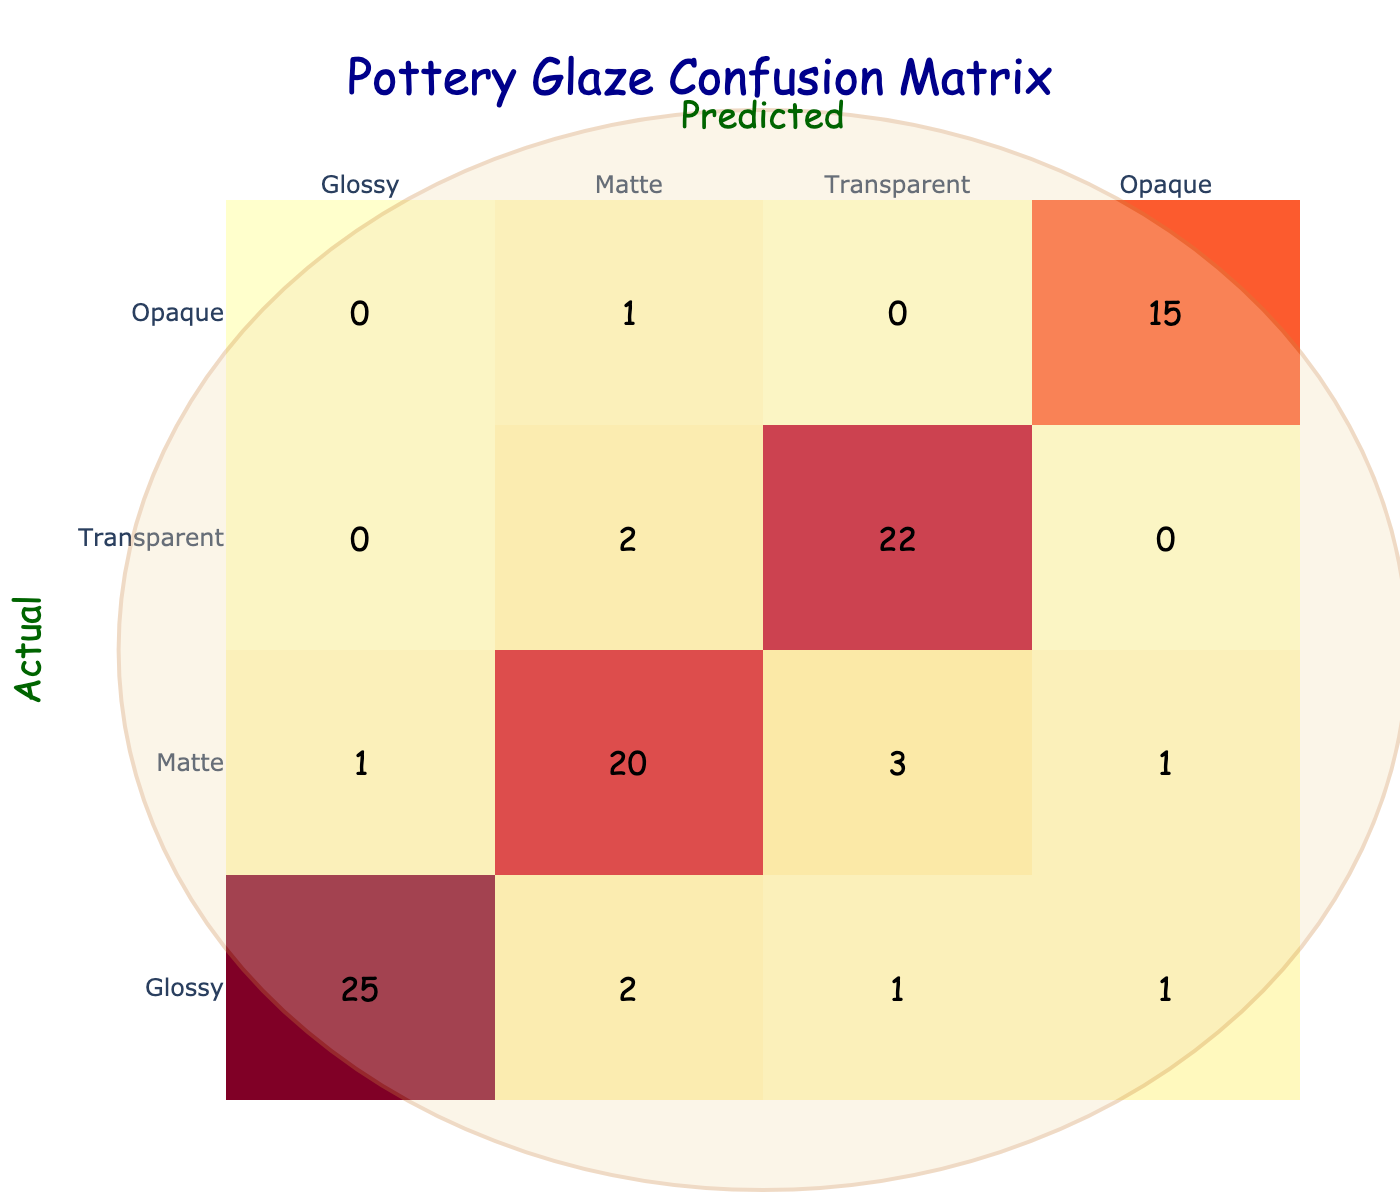What is the number of projects that were classified as Glossy and Matte? From the matrix, for the row labeled "Glossy," the number is 25 for projects correctly classified as Glossy. For the row labeled "Matte," the number is 20 for projects correctly classified as Matte. Adding these two values gives us 25 + 20 = 45.
Answer: 45 How many projects were incorrectly predicted as Transparent? The only row that predicted projects as Transparent is the row labeled "Glossy," which shows 1 project was incorrectly classified as Transparent. Additionally, "Matte" shows 3 incorrectly predicted, and "Opaque" predicts none. Adding these gives 1 + 3 + 0 = 4.
Answer: 4 Is it true that no projects were predicted as Opaque when they were actually Glossy? Looking at the row labeled "Glossy," there is a 0 in the column for Opaque, meaning that indeed, no projects were classified as Opaque when they were actually Glossy.
Answer: Yes What is the total number of projects classified as Opaque? In the Opaque row, the diagonal entry shows 15 projects correctly classified as Opaque. There are no other entries in that row, so the total is simply 15.
Answer: 15 How many more projects were classified as Matte than were classified as Glossy? For Matte, the total is 20 from the diagonal, and for Glossy, the total is 25 from its diagonal entry. The difference is calculated as 20 - 25 = -5, indicating 5 fewer Matte projects than Glossy.
Answer: 5 fewer Matte projects than Glossy What percentage of total projects were classified as Transparent? Looking at the data, the count for Transparent from the diagonal is 22 and summing all values gives us 25 + 20 + 22 + 15 = 82. The percentage is calculated as (22/82)*100 = 26.83%.
Answer: 26.83% How many projects were never classified as Transparent? By checking the Transparent column, we see that the totals from the actuals row do not include any classifications from Glossy or Opaque. The projects in these classifications sum to 25 + 20 + 0 + 15 = 60, meaning 60 projects were never classified as Transparent.
Answer: 60 What is the average number of projects that were classified correctly across all categories? The correctly classified numbers are 25 (Glossy) + 20 (Matte) + 22 (Transparent) + 15 (Opaque) = 82. There are 4 categories, so the average is calculated as 82/4 = 20.5.
Answer: 20.5 